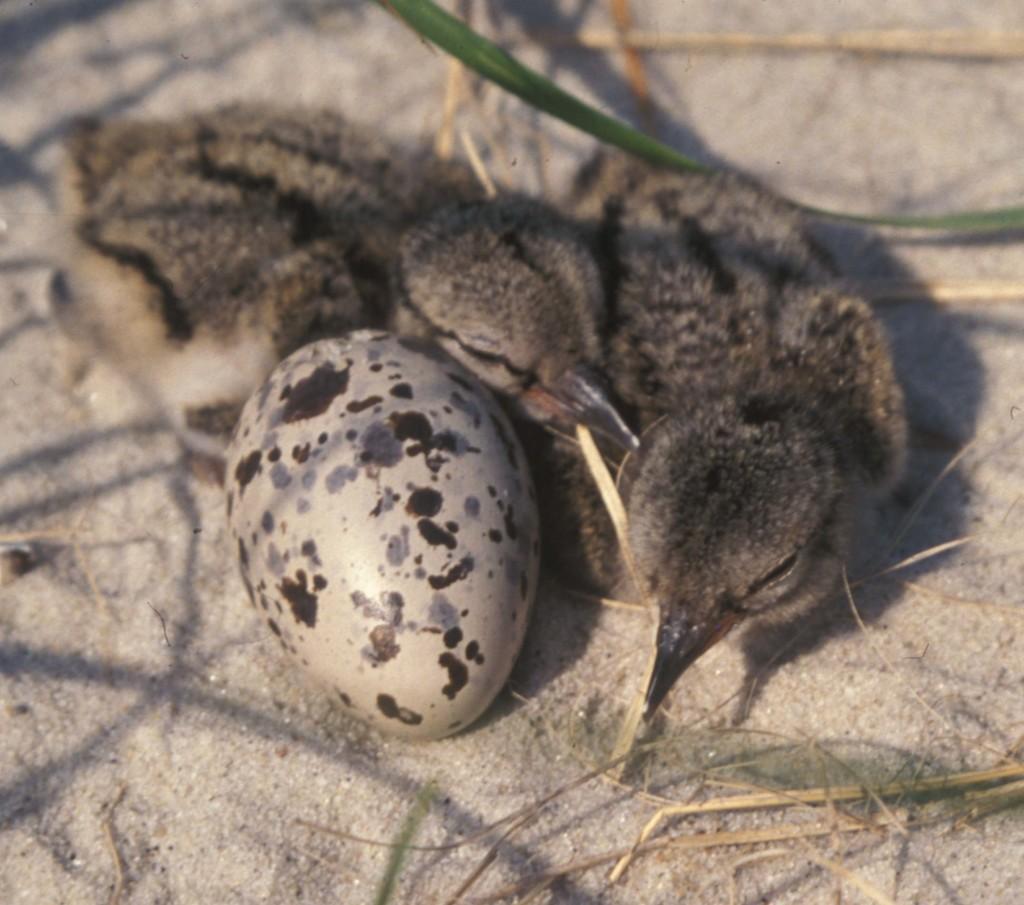Could you give a brief overview of what you see in this image? In this image there are two birds and an egg on the surface. 